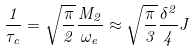<formula> <loc_0><loc_0><loc_500><loc_500>\frac { 1 } { \tau _ { c } } = \sqrt { \frac { \pi } { 2 } } \frac { M _ { 2 } } { \omega _ { e } } \approx \sqrt { \frac { \pi } { 3 } } \frac { \delta ^ { 2 } } { 4 } J</formula> 